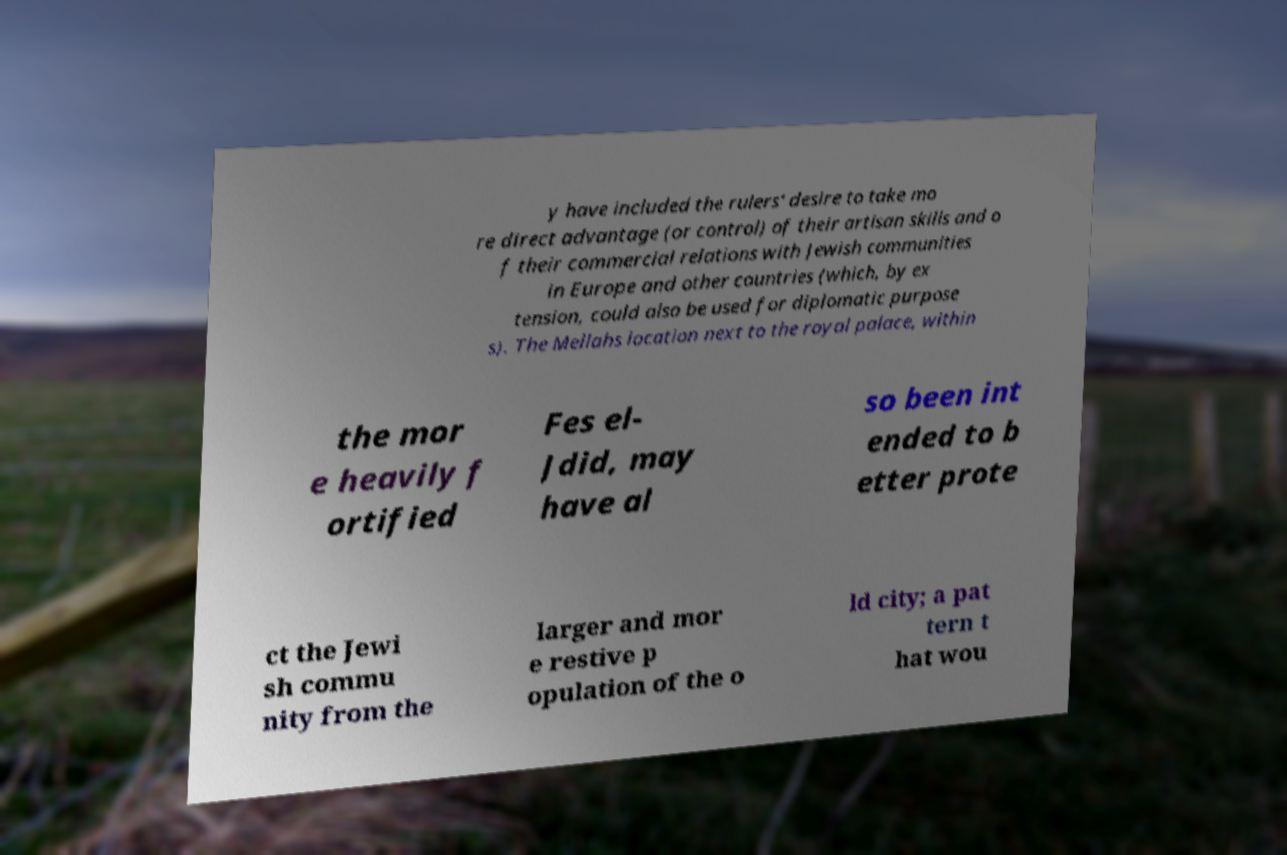What messages or text are displayed in this image? I need them in a readable, typed format. y have included the rulers' desire to take mo re direct advantage (or control) of their artisan skills and o f their commercial relations with Jewish communities in Europe and other countries (which, by ex tension, could also be used for diplomatic purpose s). The Mellahs location next to the royal palace, within the mor e heavily f ortified Fes el- Jdid, may have al so been int ended to b etter prote ct the Jewi sh commu nity from the larger and mor e restive p opulation of the o ld city; a pat tern t hat wou 